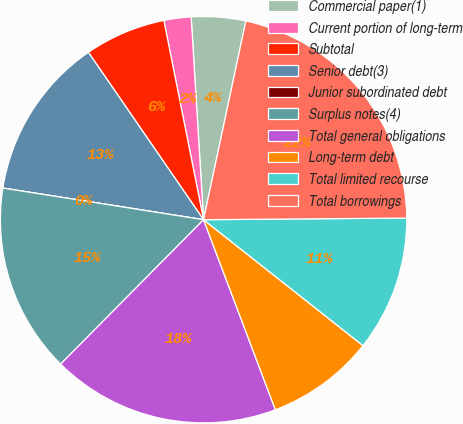Convert chart to OTSL. <chart><loc_0><loc_0><loc_500><loc_500><pie_chart><fcel>Commercial paper(1)<fcel>Current portion of long-term<fcel>Subtotal<fcel>Senior debt(3)<fcel>Junior subordinated debt<fcel>Surplus notes(4)<fcel>Total general obligations<fcel>Long-term debt<fcel>Total limited recourse<fcel>Total borrowings<nl><fcel>4.31%<fcel>2.16%<fcel>6.46%<fcel>12.92%<fcel>0.0%<fcel>15.07%<fcel>18.17%<fcel>8.61%<fcel>10.77%<fcel>21.53%<nl></chart> 